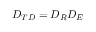<formula> <loc_0><loc_0><loc_500><loc_500>D _ { T D } = D _ { R } D _ { E }</formula> 